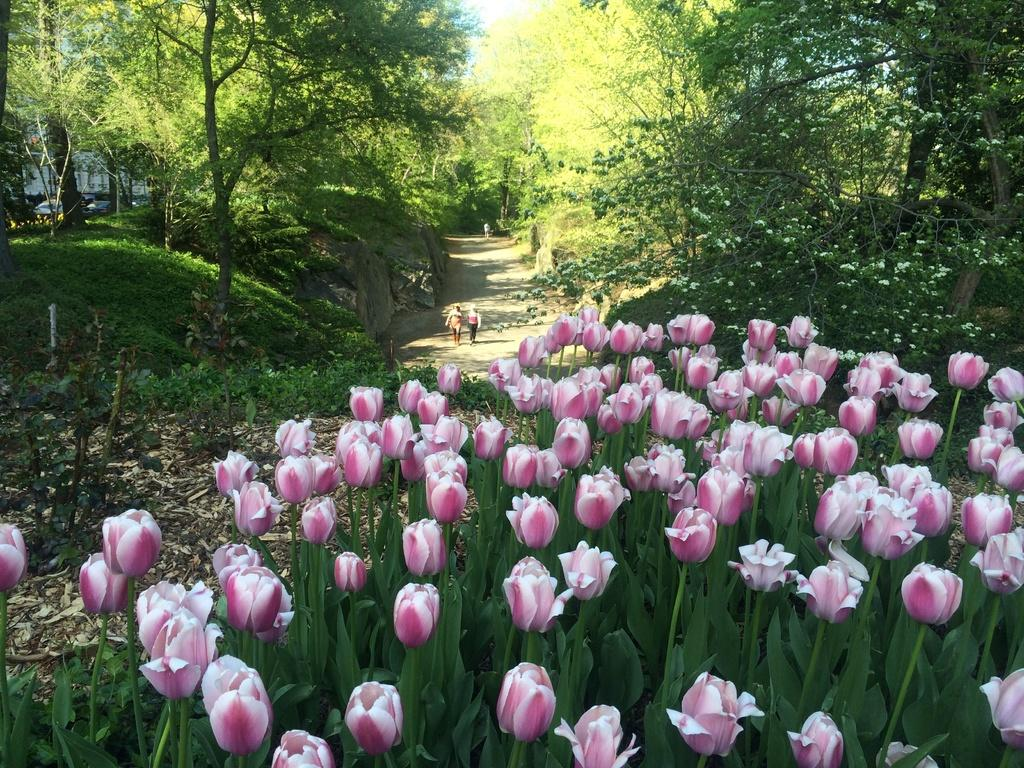What type of vegetation can be seen in the image? There are flowers, plants, and trees in the image. What can be seen in the image that might be used for walking? There is a path or way in the image. What are the two people in the image doing? Two people are walking in the image. What is the time of day in the image, and what is the wish of the flowers? The time of day cannot be determined from the image, and flowers do not have wishes. 